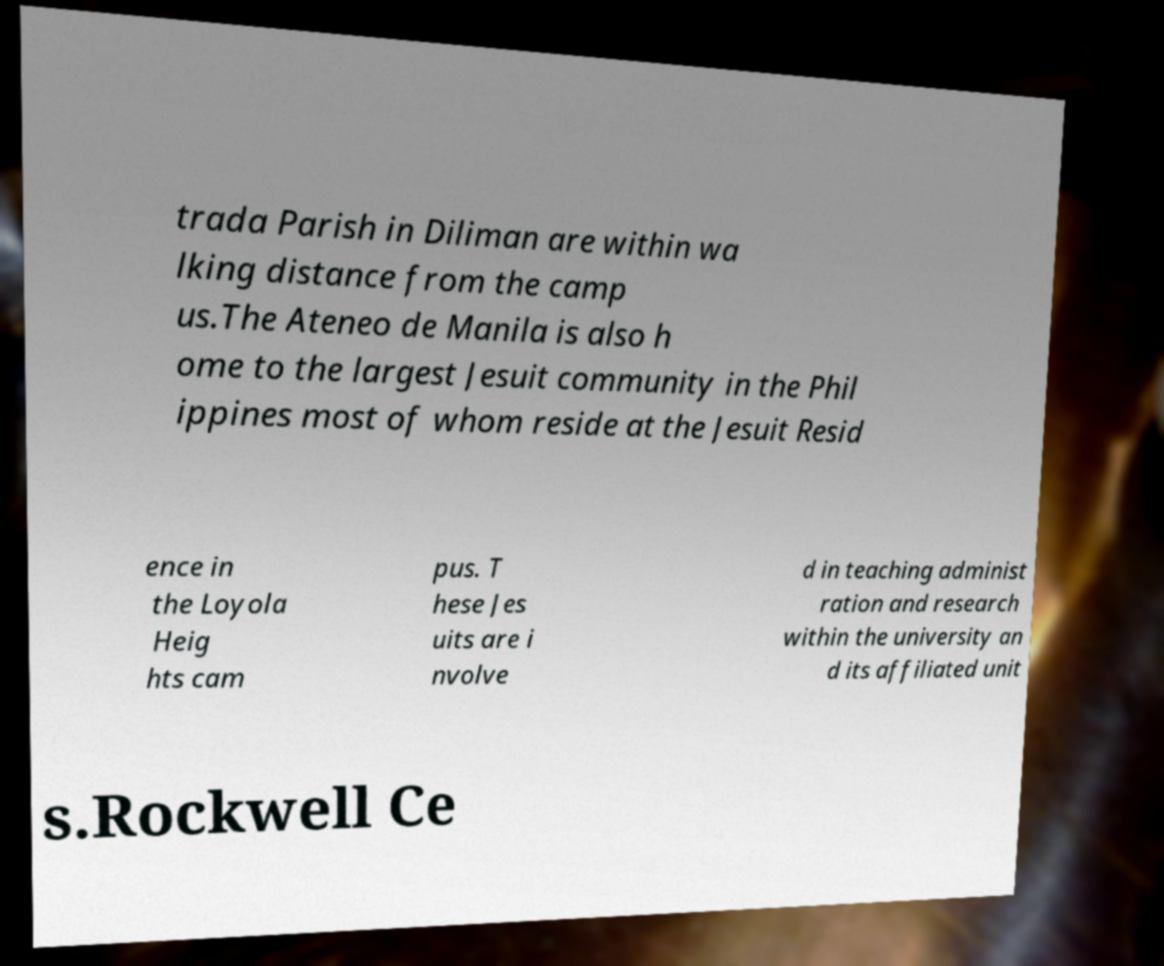I need the written content from this picture converted into text. Can you do that? trada Parish in Diliman are within wa lking distance from the camp us.The Ateneo de Manila is also h ome to the largest Jesuit community in the Phil ippines most of whom reside at the Jesuit Resid ence in the Loyola Heig hts cam pus. T hese Jes uits are i nvolve d in teaching administ ration and research within the university an d its affiliated unit s.Rockwell Ce 